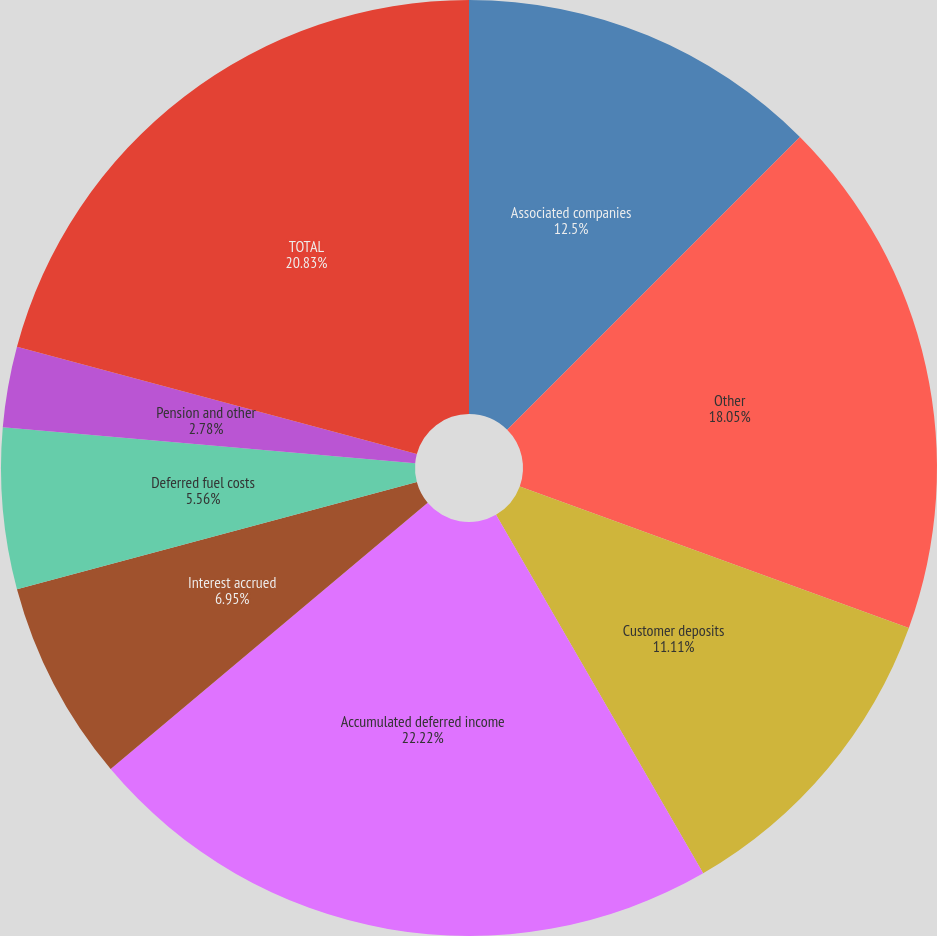Convert chart. <chart><loc_0><loc_0><loc_500><loc_500><pie_chart><fcel>Associated companies<fcel>Other<fcel>Customer deposits<fcel>Accumulated deferred income<fcel>Interest accrued<fcel>Deferred fuel costs<fcel>Pension and other<fcel>Gas hedge contracts<fcel>TOTAL<nl><fcel>12.5%<fcel>18.05%<fcel>11.11%<fcel>22.22%<fcel>6.95%<fcel>5.56%<fcel>2.78%<fcel>0.0%<fcel>20.83%<nl></chart> 